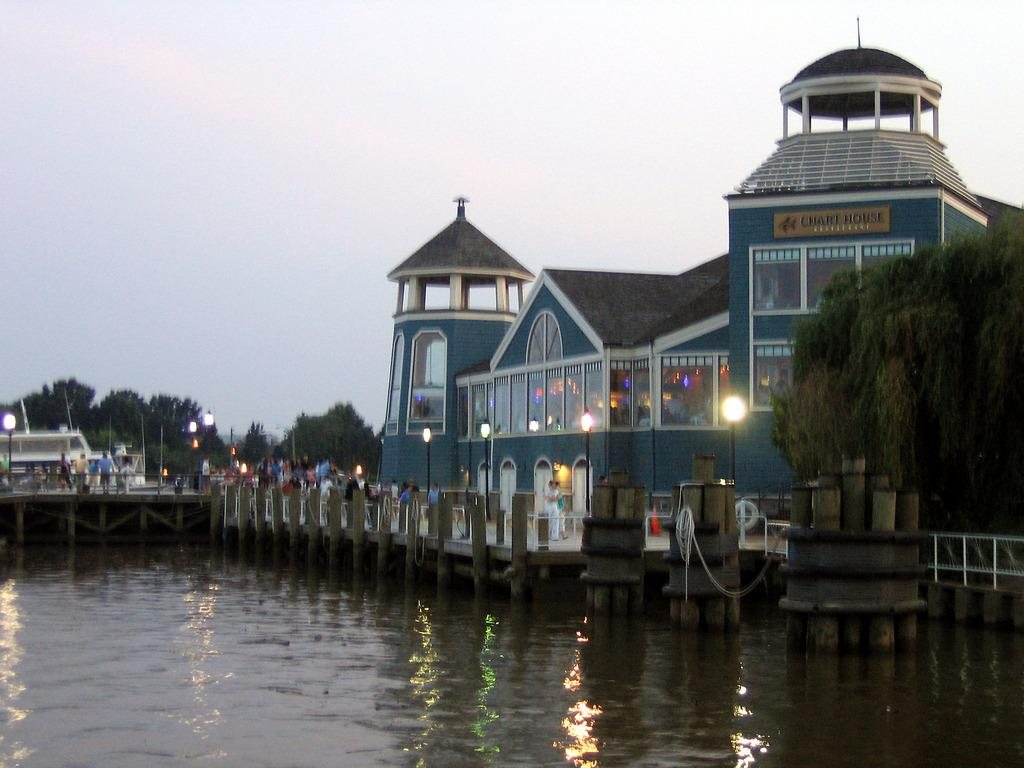<image>
Relay a brief, clear account of the picture shown. an exterior of the Chart House Restaurant overlooking the marina 